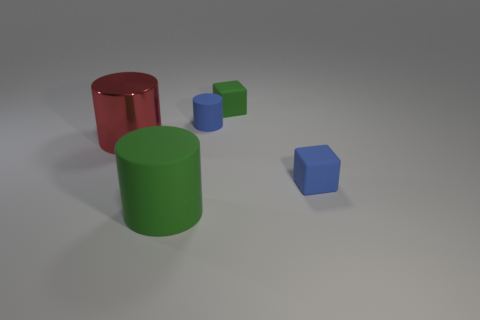Subtract all matte cylinders. How many cylinders are left? 1 Subtract all red cylinders. How many cylinders are left? 2 Add 3 cylinders. How many objects exist? 8 Subtract all cylinders. How many objects are left? 2 Add 4 tiny cylinders. How many tiny cylinders exist? 5 Subtract 0 brown blocks. How many objects are left? 5 Subtract 2 blocks. How many blocks are left? 0 Subtract all purple cylinders. Subtract all brown spheres. How many cylinders are left? 3 Subtract all red cylinders. How many green blocks are left? 1 Subtract all large rubber things. Subtract all big cylinders. How many objects are left? 2 